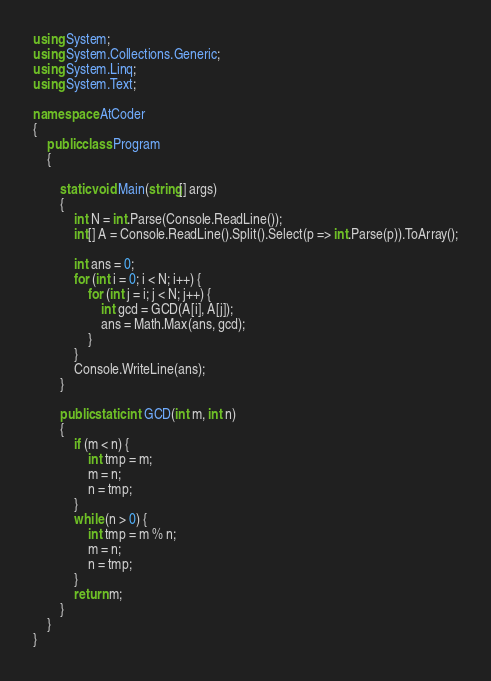<code> <loc_0><loc_0><loc_500><loc_500><_C#_>using System;
using System.Collections.Generic;
using System.Linq;
using System.Text;

namespace AtCoder
{
	public class Program
	{

		static void Main(string[] args)
		{
			int N = int.Parse(Console.ReadLine());
			int[] A = Console.ReadLine().Split().Select(p => int.Parse(p)).ToArray();

			int ans = 0;
			for (int i = 0; i < N; i++) {
				for (int j = i; j < N; j++) {
					int gcd = GCD(A[i], A[j]);
					ans = Math.Max(ans, gcd);
				}
			}
			Console.WriteLine(ans);
		}

		public static int GCD(int m, int n)
		{
			if (m < n) {
				int tmp = m;
				m = n;
				n = tmp;
			}
			while (n > 0) {
				int tmp = m % n;
				m = n;
				n = tmp;
			}
			return m;
		}
	}
}
</code> 